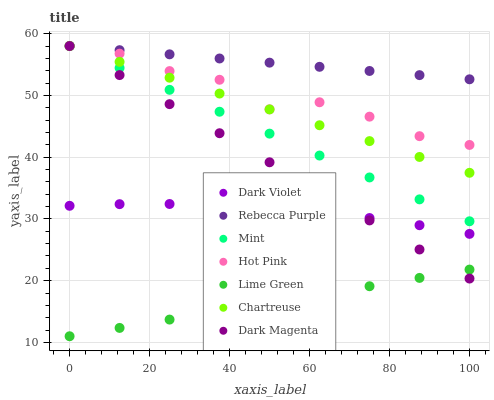Does Lime Green have the minimum area under the curve?
Answer yes or no. Yes. Does Rebecca Purple have the maximum area under the curve?
Answer yes or no. Yes. Does Mint have the minimum area under the curve?
Answer yes or no. No. Does Mint have the maximum area under the curve?
Answer yes or no. No. Is Mint the smoothest?
Answer yes or no. Yes. Is Hot Pink the roughest?
Answer yes or no. Yes. Is Hot Pink the smoothest?
Answer yes or no. No. Is Mint the roughest?
Answer yes or no. No. Does Lime Green have the lowest value?
Answer yes or no. Yes. Does Mint have the lowest value?
Answer yes or no. No. Does Rebecca Purple have the highest value?
Answer yes or no. Yes. Does Dark Violet have the highest value?
Answer yes or no. No. Is Lime Green less than Rebecca Purple?
Answer yes or no. Yes. Is Mint greater than Dark Violet?
Answer yes or no. Yes. Does Lime Green intersect Dark Magenta?
Answer yes or no. Yes. Is Lime Green less than Dark Magenta?
Answer yes or no. No. Is Lime Green greater than Dark Magenta?
Answer yes or no. No. Does Lime Green intersect Rebecca Purple?
Answer yes or no. No. 